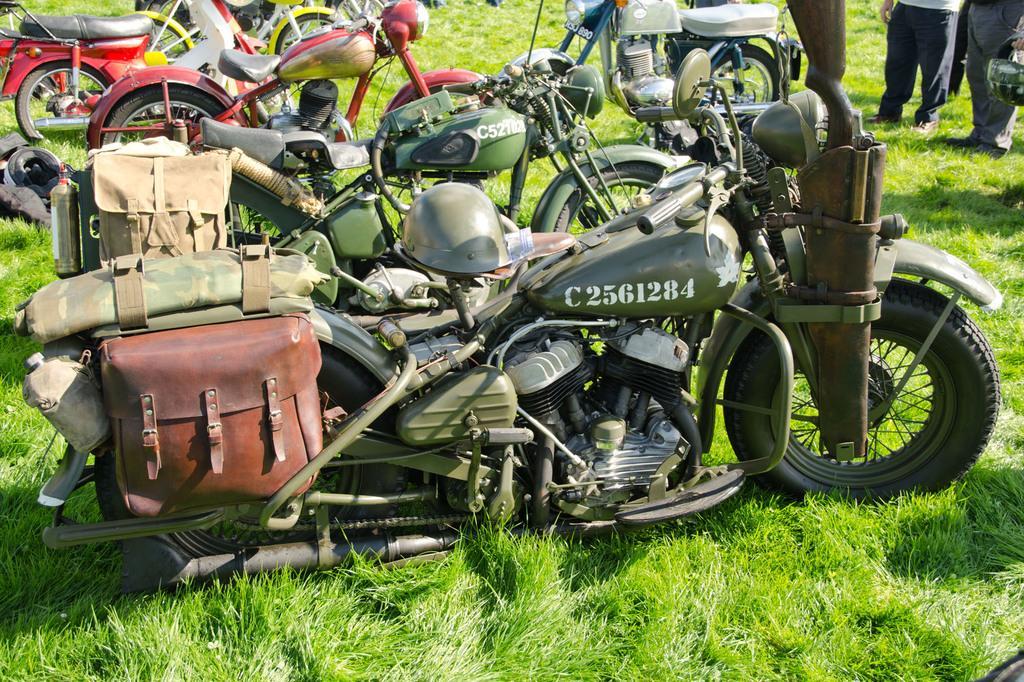Could you give a brief overview of what you see in this image? At the bottom of the image I can see the grass. Where I can see many bikes placed on the ground. In the top right, I can see two persons are standing. One person is holding a bag in the hand. 